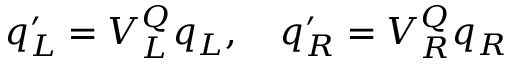Convert formula to latex. <formula><loc_0><loc_0><loc_500><loc_500>q _ { L } ^ { \prime } = V _ { L } ^ { Q } q _ { L } , \quad q _ { R } ^ { \prime } = V _ { R } ^ { Q } q _ { R }</formula> 